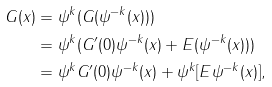Convert formula to latex. <formula><loc_0><loc_0><loc_500><loc_500>G ( x ) & = \psi ^ { k } ( G ( \psi ^ { - k } ( x ) ) ) \\ & = \psi ^ { k } ( G ^ { \prime } ( 0 ) \psi ^ { - k } ( x ) + E ( \psi ^ { - k } ( x ) ) ) \\ & = \psi ^ { k } G ^ { \prime } ( 0 ) \psi ^ { - k } ( x ) + \psi ^ { k } [ E \psi ^ { - k } ( x ) ] ,</formula> 